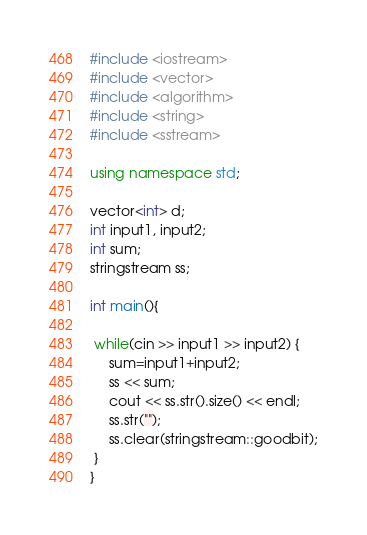<code> <loc_0><loc_0><loc_500><loc_500><_C++_>#include <iostream>
#include <vector>
#include <algorithm>
#include <string>
#include <sstream>
 
using namespace std;
 
vector<int> d;
int input1, input2;
int sum;
stringstream ss;
 
int main(){
    
 while(cin >> input1 >> input2) {
     sum=input1+input2;
     ss << sum;
     cout << ss.str().size() << endl;
     ss.str("");
     ss.clear(stringstream::goodbit);
 }
}</code> 